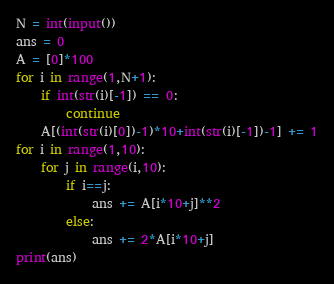<code> <loc_0><loc_0><loc_500><loc_500><_Python_>N = int(input())
ans = 0
A = [0]*100
for i in range(1,N+1):
    if int(str(i)[-1]) == 0:
        continue
    A[(int(str(i)[0])-1)*10+int(str(i)[-1])-1] += 1
for i in range(1,10):
    for j in range(i,10):
        if i==j:
            ans += A[i*10+j]**2
        else:
            ans += 2*A[i*10+j]
print(ans) </code> 